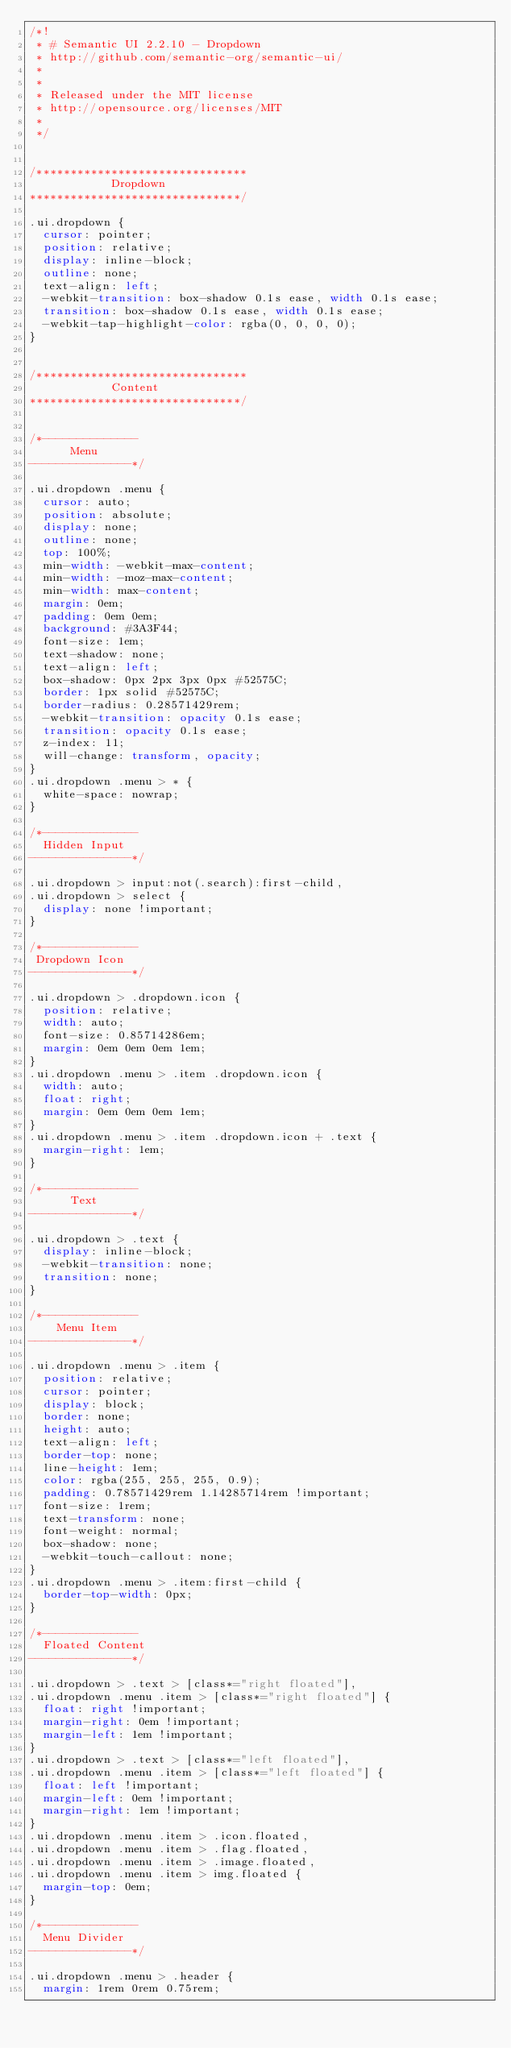<code> <loc_0><loc_0><loc_500><loc_500><_CSS_>/*!
 * # Semantic UI 2.2.10 - Dropdown
 * http://github.com/semantic-org/semantic-ui/
 *
 *
 * Released under the MIT license
 * http://opensource.org/licenses/MIT
 *
 */


/*******************************
            Dropdown
*******************************/

.ui.dropdown {
  cursor: pointer;
  position: relative;
  display: inline-block;
  outline: none;
  text-align: left;
  -webkit-transition: box-shadow 0.1s ease, width 0.1s ease;
  transition: box-shadow 0.1s ease, width 0.1s ease;
  -webkit-tap-highlight-color: rgba(0, 0, 0, 0);
}


/*******************************
            Content
*******************************/


/*--------------
      Menu
---------------*/

.ui.dropdown .menu {
  cursor: auto;
  position: absolute;
  display: none;
  outline: none;
  top: 100%;
  min-width: -webkit-max-content;
  min-width: -moz-max-content;
  min-width: max-content;
  margin: 0em;
  padding: 0em 0em;
  background: #3A3F44;
  font-size: 1em;
  text-shadow: none;
  text-align: left;
  box-shadow: 0px 2px 3px 0px #52575C;
  border: 1px solid #52575C;
  border-radius: 0.28571429rem;
  -webkit-transition: opacity 0.1s ease;
  transition: opacity 0.1s ease;
  z-index: 11;
  will-change: transform, opacity;
}
.ui.dropdown .menu > * {
  white-space: nowrap;
}

/*--------------
  Hidden Input
---------------*/

.ui.dropdown > input:not(.search):first-child,
.ui.dropdown > select {
  display: none !important;
}

/*--------------
 Dropdown Icon
---------------*/

.ui.dropdown > .dropdown.icon {
  position: relative;
  width: auto;
  font-size: 0.85714286em;
  margin: 0em 0em 0em 1em;
}
.ui.dropdown .menu > .item .dropdown.icon {
  width: auto;
  float: right;
  margin: 0em 0em 0em 1em;
}
.ui.dropdown .menu > .item .dropdown.icon + .text {
  margin-right: 1em;
}

/*--------------
      Text
---------------*/

.ui.dropdown > .text {
  display: inline-block;
  -webkit-transition: none;
  transition: none;
}

/*--------------
    Menu Item
---------------*/

.ui.dropdown .menu > .item {
  position: relative;
  cursor: pointer;
  display: block;
  border: none;
  height: auto;
  text-align: left;
  border-top: none;
  line-height: 1em;
  color: rgba(255, 255, 255, 0.9);
  padding: 0.78571429rem 1.14285714rem !important;
  font-size: 1rem;
  text-transform: none;
  font-weight: normal;
  box-shadow: none;
  -webkit-touch-callout: none;
}
.ui.dropdown .menu > .item:first-child {
  border-top-width: 0px;
}

/*--------------
  Floated Content
---------------*/

.ui.dropdown > .text > [class*="right floated"],
.ui.dropdown .menu .item > [class*="right floated"] {
  float: right !important;
  margin-right: 0em !important;
  margin-left: 1em !important;
}
.ui.dropdown > .text > [class*="left floated"],
.ui.dropdown .menu .item > [class*="left floated"] {
  float: left !important;
  margin-left: 0em !important;
  margin-right: 1em !important;
}
.ui.dropdown .menu .item > .icon.floated,
.ui.dropdown .menu .item > .flag.floated,
.ui.dropdown .menu .item > .image.floated,
.ui.dropdown .menu .item > img.floated {
  margin-top: 0em;
}

/*--------------
  Menu Divider
---------------*/

.ui.dropdown .menu > .header {
  margin: 1rem 0rem 0.75rem;</code> 